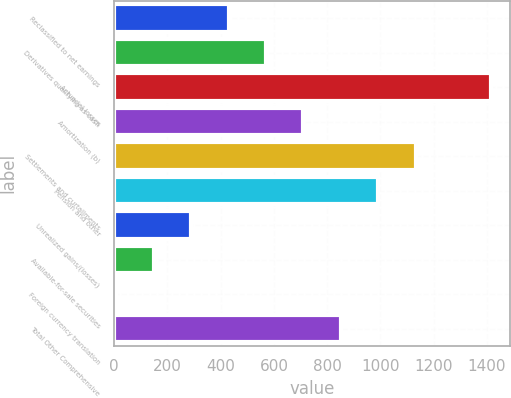Convert chart. <chart><loc_0><loc_0><loc_500><loc_500><bar_chart><fcel>Reclassified to net earnings<fcel>Derivatives qualifying as cash<fcel>Actuarial losses<fcel>Amortization (b)<fcel>Settlements and curtailments<fcel>Pension and other<fcel>Unrealized gains/(losses)<fcel>Available-for-sale securities<fcel>Foreign currency translation<fcel>Total Other Comprehensive<nl><fcel>429.8<fcel>570.4<fcel>1414<fcel>711<fcel>1132.8<fcel>992.2<fcel>289.2<fcel>148.6<fcel>8<fcel>851.6<nl></chart> 